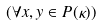Convert formula to latex. <formula><loc_0><loc_0><loc_500><loc_500>( \forall x , y \in P ( \kappa ) )</formula> 